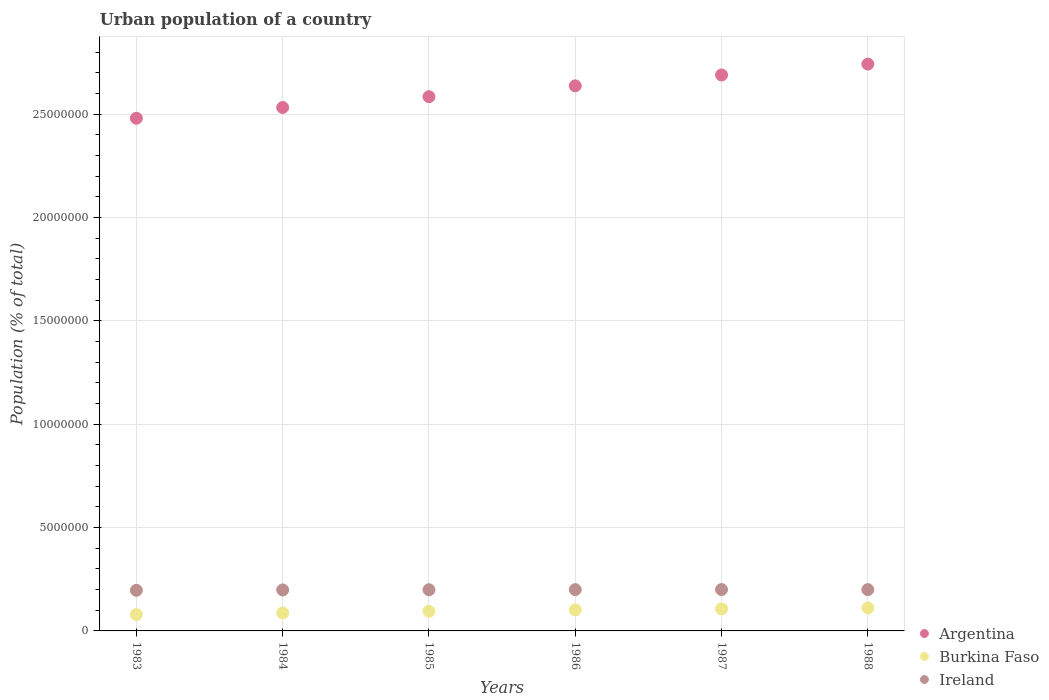Is the number of dotlines equal to the number of legend labels?
Offer a terse response. Yes. What is the urban population in Argentina in 1988?
Keep it short and to the point. 2.74e+07. Across all years, what is the maximum urban population in Ireland?
Provide a short and direct response. 2.00e+06. Across all years, what is the minimum urban population in Argentina?
Offer a very short reply. 2.48e+07. What is the total urban population in Burkina Faso in the graph?
Your response must be concise. 5.81e+06. What is the difference between the urban population in Burkina Faso in 1984 and that in 1987?
Your answer should be compact. -1.95e+05. What is the difference between the urban population in Ireland in 1985 and the urban population in Argentina in 1986?
Your answer should be very brief. -2.44e+07. What is the average urban population in Burkina Faso per year?
Give a very brief answer. 9.68e+05. In the year 1986, what is the difference between the urban population in Argentina and urban population in Burkina Faso?
Your response must be concise. 2.53e+07. What is the ratio of the urban population in Burkina Faso in 1983 to that in 1985?
Provide a succinct answer. 0.83. Is the difference between the urban population in Argentina in 1987 and 1988 greater than the difference between the urban population in Burkina Faso in 1987 and 1988?
Your answer should be compact. No. What is the difference between the highest and the second highest urban population in Burkina Faso?
Offer a terse response. 4.87e+04. What is the difference between the highest and the lowest urban population in Burkina Faso?
Provide a succinct answer. 3.20e+05. Does the urban population in Burkina Faso monotonically increase over the years?
Offer a very short reply. Yes. Is the urban population in Burkina Faso strictly greater than the urban population in Argentina over the years?
Keep it short and to the point. No. Is the urban population in Burkina Faso strictly less than the urban population in Ireland over the years?
Make the answer very short. Yes. How many years are there in the graph?
Keep it short and to the point. 6. What is the difference between two consecutive major ticks on the Y-axis?
Ensure brevity in your answer.  5.00e+06. How many legend labels are there?
Provide a succinct answer. 3. How are the legend labels stacked?
Provide a succinct answer. Vertical. What is the title of the graph?
Give a very brief answer. Urban population of a country. What is the label or title of the Y-axis?
Your response must be concise. Population (% of total). What is the Population (% of total) in Argentina in 1983?
Your response must be concise. 2.48e+07. What is the Population (% of total) of Burkina Faso in 1983?
Keep it short and to the point. 7.93e+05. What is the Population (% of total) of Ireland in 1983?
Give a very brief answer. 1.96e+06. What is the Population (% of total) of Argentina in 1984?
Keep it short and to the point. 2.53e+07. What is the Population (% of total) in Burkina Faso in 1984?
Make the answer very short. 8.69e+05. What is the Population (% of total) of Ireland in 1984?
Your answer should be compact. 1.98e+06. What is the Population (% of total) of Argentina in 1985?
Ensure brevity in your answer.  2.58e+07. What is the Population (% of total) in Burkina Faso in 1985?
Make the answer very short. 9.53e+05. What is the Population (% of total) in Ireland in 1985?
Provide a succinct answer. 1.99e+06. What is the Population (% of total) of Argentina in 1986?
Your response must be concise. 2.64e+07. What is the Population (% of total) in Burkina Faso in 1986?
Provide a succinct answer. 1.02e+06. What is the Population (% of total) of Ireland in 1986?
Your answer should be compact. 2.00e+06. What is the Population (% of total) of Argentina in 1987?
Offer a very short reply. 2.69e+07. What is the Population (% of total) in Burkina Faso in 1987?
Provide a short and direct response. 1.06e+06. What is the Population (% of total) of Ireland in 1987?
Ensure brevity in your answer.  2.00e+06. What is the Population (% of total) in Argentina in 1988?
Keep it short and to the point. 2.74e+07. What is the Population (% of total) of Burkina Faso in 1988?
Give a very brief answer. 1.11e+06. What is the Population (% of total) of Ireland in 1988?
Ensure brevity in your answer.  2.00e+06. Across all years, what is the maximum Population (% of total) of Argentina?
Offer a terse response. 2.74e+07. Across all years, what is the maximum Population (% of total) in Burkina Faso?
Ensure brevity in your answer.  1.11e+06. Across all years, what is the maximum Population (% of total) of Ireland?
Offer a terse response. 2.00e+06. Across all years, what is the minimum Population (% of total) of Argentina?
Offer a terse response. 2.48e+07. Across all years, what is the minimum Population (% of total) of Burkina Faso?
Offer a very short reply. 7.93e+05. Across all years, what is the minimum Population (% of total) in Ireland?
Provide a short and direct response. 1.96e+06. What is the total Population (% of total) of Argentina in the graph?
Your answer should be very brief. 1.57e+08. What is the total Population (% of total) of Burkina Faso in the graph?
Your answer should be very brief. 5.81e+06. What is the total Population (% of total) of Ireland in the graph?
Ensure brevity in your answer.  1.19e+07. What is the difference between the Population (% of total) of Argentina in 1983 and that in 1984?
Offer a very short reply. -5.20e+05. What is the difference between the Population (% of total) of Burkina Faso in 1983 and that in 1984?
Your response must be concise. -7.69e+04. What is the difference between the Population (% of total) of Ireland in 1983 and that in 1984?
Make the answer very short. -1.79e+04. What is the difference between the Population (% of total) of Argentina in 1983 and that in 1985?
Offer a very short reply. -1.04e+06. What is the difference between the Population (% of total) in Burkina Faso in 1983 and that in 1985?
Ensure brevity in your answer.  -1.61e+05. What is the difference between the Population (% of total) in Ireland in 1983 and that in 1985?
Make the answer very short. -2.67e+04. What is the difference between the Population (% of total) in Argentina in 1983 and that in 1986?
Your response must be concise. -1.57e+06. What is the difference between the Population (% of total) of Burkina Faso in 1983 and that in 1986?
Provide a succinct answer. -2.25e+05. What is the difference between the Population (% of total) in Ireland in 1983 and that in 1986?
Ensure brevity in your answer.  -3.29e+04. What is the difference between the Population (% of total) in Argentina in 1983 and that in 1987?
Provide a short and direct response. -2.09e+06. What is the difference between the Population (% of total) in Burkina Faso in 1983 and that in 1987?
Keep it short and to the point. -2.72e+05. What is the difference between the Population (% of total) in Ireland in 1983 and that in 1987?
Keep it short and to the point. -3.74e+04. What is the difference between the Population (% of total) of Argentina in 1983 and that in 1988?
Offer a very short reply. -2.62e+06. What is the difference between the Population (% of total) of Burkina Faso in 1983 and that in 1988?
Your response must be concise. -3.20e+05. What is the difference between the Population (% of total) in Ireland in 1983 and that in 1988?
Give a very brief answer. -3.31e+04. What is the difference between the Population (% of total) of Argentina in 1984 and that in 1985?
Offer a very short reply. -5.23e+05. What is the difference between the Population (% of total) in Burkina Faso in 1984 and that in 1985?
Offer a very short reply. -8.38e+04. What is the difference between the Population (% of total) in Ireland in 1984 and that in 1985?
Your answer should be compact. -8837. What is the difference between the Population (% of total) in Argentina in 1984 and that in 1986?
Your response must be concise. -1.05e+06. What is the difference between the Population (% of total) in Burkina Faso in 1984 and that in 1986?
Offer a terse response. -1.48e+05. What is the difference between the Population (% of total) in Ireland in 1984 and that in 1986?
Your answer should be very brief. -1.51e+04. What is the difference between the Population (% of total) in Argentina in 1984 and that in 1987?
Give a very brief answer. -1.57e+06. What is the difference between the Population (% of total) of Burkina Faso in 1984 and that in 1987?
Offer a terse response. -1.95e+05. What is the difference between the Population (% of total) of Ireland in 1984 and that in 1987?
Your answer should be compact. -1.95e+04. What is the difference between the Population (% of total) of Argentina in 1984 and that in 1988?
Ensure brevity in your answer.  -2.10e+06. What is the difference between the Population (% of total) of Burkina Faso in 1984 and that in 1988?
Your answer should be compact. -2.43e+05. What is the difference between the Population (% of total) of Ireland in 1984 and that in 1988?
Offer a very short reply. -1.52e+04. What is the difference between the Population (% of total) of Argentina in 1985 and that in 1986?
Offer a very short reply. -5.24e+05. What is the difference between the Population (% of total) in Burkina Faso in 1985 and that in 1986?
Your answer should be compact. -6.45e+04. What is the difference between the Population (% of total) of Ireland in 1985 and that in 1986?
Provide a short and direct response. -6249. What is the difference between the Population (% of total) of Argentina in 1985 and that in 1987?
Your answer should be very brief. -1.05e+06. What is the difference between the Population (% of total) of Burkina Faso in 1985 and that in 1987?
Offer a terse response. -1.11e+05. What is the difference between the Population (% of total) of Ireland in 1985 and that in 1987?
Provide a succinct answer. -1.07e+04. What is the difference between the Population (% of total) of Argentina in 1985 and that in 1988?
Your answer should be very brief. -1.58e+06. What is the difference between the Population (% of total) of Burkina Faso in 1985 and that in 1988?
Keep it short and to the point. -1.60e+05. What is the difference between the Population (% of total) of Ireland in 1985 and that in 1988?
Provide a succinct answer. -6392. What is the difference between the Population (% of total) of Argentina in 1986 and that in 1987?
Your response must be concise. -5.26e+05. What is the difference between the Population (% of total) in Burkina Faso in 1986 and that in 1987?
Offer a very short reply. -4.64e+04. What is the difference between the Population (% of total) of Ireland in 1986 and that in 1987?
Provide a short and direct response. -4456. What is the difference between the Population (% of total) in Argentina in 1986 and that in 1988?
Your response must be concise. -1.05e+06. What is the difference between the Population (% of total) of Burkina Faso in 1986 and that in 1988?
Offer a very short reply. -9.51e+04. What is the difference between the Population (% of total) in Ireland in 1986 and that in 1988?
Your answer should be compact. -143. What is the difference between the Population (% of total) in Argentina in 1987 and that in 1988?
Provide a succinct answer. -5.27e+05. What is the difference between the Population (% of total) of Burkina Faso in 1987 and that in 1988?
Give a very brief answer. -4.87e+04. What is the difference between the Population (% of total) in Ireland in 1987 and that in 1988?
Provide a short and direct response. 4313. What is the difference between the Population (% of total) in Argentina in 1983 and the Population (% of total) in Burkina Faso in 1984?
Keep it short and to the point. 2.39e+07. What is the difference between the Population (% of total) of Argentina in 1983 and the Population (% of total) of Ireland in 1984?
Make the answer very short. 2.28e+07. What is the difference between the Population (% of total) of Burkina Faso in 1983 and the Population (% of total) of Ireland in 1984?
Provide a succinct answer. -1.19e+06. What is the difference between the Population (% of total) of Argentina in 1983 and the Population (% of total) of Burkina Faso in 1985?
Keep it short and to the point. 2.38e+07. What is the difference between the Population (% of total) of Argentina in 1983 and the Population (% of total) of Ireland in 1985?
Your answer should be compact. 2.28e+07. What is the difference between the Population (% of total) in Burkina Faso in 1983 and the Population (% of total) in Ireland in 1985?
Offer a very short reply. -1.20e+06. What is the difference between the Population (% of total) in Argentina in 1983 and the Population (% of total) in Burkina Faso in 1986?
Your answer should be very brief. 2.38e+07. What is the difference between the Population (% of total) of Argentina in 1983 and the Population (% of total) of Ireland in 1986?
Your answer should be compact. 2.28e+07. What is the difference between the Population (% of total) of Burkina Faso in 1983 and the Population (% of total) of Ireland in 1986?
Your answer should be compact. -1.20e+06. What is the difference between the Population (% of total) in Argentina in 1983 and the Population (% of total) in Burkina Faso in 1987?
Offer a terse response. 2.37e+07. What is the difference between the Population (% of total) of Argentina in 1983 and the Population (% of total) of Ireland in 1987?
Your answer should be compact. 2.28e+07. What is the difference between the Population (% of total) in Burkina Faso in 1983 and the Population (% of total) in Ireland in 1987?
Provide a succinct answer. -1.21e+06. What is the difference between the Population (% of total) in Argentina in 1983 and the Population (% of total) in Burkina Faso in 1988?
Offer a terse response. 2.37e+07. What is the difference between the Population (% of total) in Argentina in 1983 and the Population (% of total) in Ireland in 1988?
Make the answer very short. 2.28e+07. What is the difference between the Population (% of total) of Burkina Faso in 1983 and the Population (% of total) of Ireland in 1988?
Your response must be concise. -1.20e+06. What is the difference between the Population (% of total) in Argentina in 1984 and the Population (% of total) in Burkina Faso in 1985?
Give a very brief answer. 2.44e+07. What is the difference between the Population (% of total) in Argentina in 1984 and the Population (% of total) in Ireland in 1985?
Ensure brevity in your answer.  2.33e+07. What is the difference between the Population (% of total) of Burkina Faso in 1984 and the Population (% of total) of Ireland in 1985?
Make the answer very short. -1.12e+06. What is the difference between the Population (% of total) in Argentina in 1984 and the Population (% of total) in Burkina Faso in 1986?
Your response must be concise. 2.43e+07. What is the difference between the Population (% of total) in Argentina in 1984 and the Population (% of total) in Ireland in 1986?
Your answer should be compact. 2.33e+07. What is the difference between the Population (% of total) of Burkina Faso in 1984 and the Population (% of total) of Ireland in 1986?
Your response must be concise. -1.13e+06. What is the difference between the Population (% of total) of Argentina in 1984 and the Population (% of total) of Burkina Faso in 1987?
Keep it short and to the point. 2.43e+07. What is the difference between the Population (% of total) in Argentina in 1984 and the Population (% of total) in Ireland in 1987?
Your answer should be very brief. 2.33e+07. What is the difference between the Population (% of total) in Burkina Faso in 1984 and the Population (% of total) in Ireland in 1987?
Offer a terse response. -1.13e+06. What is the difference between the Population (% of total) of Argentina in 1984 and the Population (% of total) of Burkina Faso in 1988?
Offer a very short reply. 2.42e+07. What is the difference between the Population (% of total) of Argentina in 1984 and the Population (% of total) of Ireland in 1988?
Offer a very short reply. 2.33e+07. What is the difference between the Population (% of total) of Burkina Faso in 1984 and the Population (% of total) of Ireland in 1988?
Make the answer very short. -1.13e+06. What is the difference between the Population (% of total) in Argentina in 1985 and the Population (% of total) in Burkina Faso in 1986?
Offer a terse response. 2.48e+07. What is the difference between the Population (% of total) of Argentina in 1985 and the Population (% of total) of Ireland in 1986?
Make the answer very short. 2.38e+07. What is the difference between the Population (% of total) of Burkina Faso in 1985 and the Population (% of total) of Ireland in 1986?
Ensure brevity in your answer.  -1.04e+06. What is the difference between the Population (% of total) in Argentina in 1985 and the Population (% of total) in Burkina Faso in 1987?
Give a very brief answer. 2.48e+07. What is the difference between the Population (% of total) of Argentina in 1985 and the Population (% of total) of Ireland in 1987?
Offer a very short reply. 2.38e+07. What is the difference between the Population (% of total) of Burkina Faso in 1985 and the Population (% of total) of Ireland in 1987?
Provide a short and direct response. -1.05e+06. What is the difference between the Population (% of total) of Argentina in 1985 and the Population (% of total) of Burkina Faso in 1988?
Provide a succinct answer. 2.47e+07. What is the difference between the Population (% of total) in Argentina in 1985 and the Population (% of total) in Ireland in 1988?
Offer a very short reply. 2.38e+07. What is the difference between the Population (% of total) in Burkina Faso in 1985 and the Population (% of total) in Ireland in 1988?
Make the answer very short. -1.04e+06. What is the difference between the Population (% of total) in Argentina in 1986 and the Population (% of total) in Burkina Faso in 1987?
Your response must be concise. 2.53e+07. What is the difference between the Population (% of total) in Argentina in 1986 and the Population (% of total) in Ireland in 1987?
Ensure brevity in your answer.  2.44e+07. What is the difference between the Population (% of total) of Burkina Faso in 1986 and the Population (% of total) of Ireland in 1987?
Your answer should be compact. -9.84e+05. What is the difference between the Population (% of total) in Argentina in 1986 and the Population (% of total) in Burkina Faso in 1988?
Give a very brief answer. 2.53e+07. What is the difference between the Population (% of total) in Argentina in 1986 and the Population (% of total) in Ireland in 1988?
Provide a short and direct response. 2.44e+07. What is the difference between the Population (% of total) in Burkina Faso in 1986 and the Population (% of total) in Ireland in 1988?
Keep it short and to the point. -9.80e+05. What is the difference between the Population (% of total) in Argentina in 1987 and the Population (% of total) in Burkina Faso in 1988?
Make the answer very short. 2.58e+07. What is the difference between the Population (% of total) of Argentina in 1987 and the Population (% of total) of Ireland in 1988?
Your answer should be compact. 2.49e+07. What is the difference between the Population (% of total) of Burkina Faso in 1987 and the Population (% of total) of Ireland in 1988?
Your response must be concise. -9.33e+05. What is the average Population (% of total) in Argentina per year?
Your response must be concise. 2.61e+07. What is the average Population (% of total) in Burkina Faso per year?
Your answer should be compact. 9.68e+05. What is the average Population (% of total) in Ireland per year?
Offer a very short reply. 1.99e+06. In the year 1983, what is the difference between the Population (% of total) of Argentina and Population (% of total) of Burkina Faso?
Your answer should be very brief. 2.40e+07. In the year 1983, what is the difference between the Population (% of total) of Argentina and Population (% of total) of Ireland?
Provide a short and direct response. 2.28e+07. In the year 1983, what is the difference between the Population (% of total) in Burkina Faso and Population (% of total) in Ireland?
Offer a very short reply. -1.17e+06. In the year 1984, what is the difference between the Population (% of total) in Argentina and Population (% of total) in Burkina Faso?
Your response must be concise. 2.44e+07. In the year 1984, what is the difference between the Population (% of total) in Argentina and Population (% of total) in Ireland?
Ensure brevity in your answer.  2.33e+07. In the year 1984, what is the difference between the Population (% of total) of Burkina Faso and Population (% of total) of Ireland?
Keep it short and to the point. -1.11e+06. In the year 1985, what is the difference between the Population (% of total) in Argentina and Population (% of total) in Burkina Faso?
Make the answer very short. 2.49e+07. In the year 1985, what is the difference between the Population (% of total) in Argentina and Population (% of total) in Ireland?
Provide a short and direct response. 2.39e+07. In the year 1985, what is the difference between the Population (% of total) of Burkina Faso and Population (% of total) of Ireland?
Your response must be concise. -1.04e+06. In the year 1986, what is the difference between the Population (% of total) in Argentina and Population (% of total) in Burkina Faso?
Your answer should be very brief. 2.53e+07. In the year 1986, what is the difference between the Population (% of total) in Argentina and Population (% of total) in Ireland?
Make the answer very short. 2.44e+07. In the year 1986, what is the difference between the Population (% of total) in Burkina Faso and Population (% of total) in Ireland?
Your answer should be very brief. -9.80e+05. In the year 1987, what is the difference between the Population (% of total) of Argentina and Population (% of total) of Burkina Faso?
Make the answer very short. 2.58e+07. In the year 1987, what is the difference between the Population (% of total) of Argentina and Population (% of total) of Ireland?
Give a very brief answer. 2.49e+07. In the year 1987, what is the difference between the Population (% of total) in Burkina Faso and Population (% of total) in Ireland?
Keep it short and to the point. -9.38e+05. In the year 1988, what is the difference between the Population (% of total) in Argentina and Population (% of total) in Burkina Faso?
Provide a succinct answer. 2.63e+07. In the year 1988, what is the difference between the Population (% of total) of Argentina and Population (% of total) of Ireland?
Your answer should be compact. 2.54e+07. In the year 1988, what is the difference between the Population (% of total) of Burkina Faso and Population (% of total) of Ireland?
Provide a short and direct response. -8.85e+05. What is the ratio of the Population (% of total) in Argentina in 1983 to that in 1984?
Provide a short and direct response. 0.98. What is the ratio of the Population (% of total) of Burkina Faso in 1983 to that in 1984?
Your answer should be very brief. 0.91. What is the ratio of the Population (% of total) of Argentina in 1983 to that in 1985?
Your response must be concise. 0.96. What is the ratio of the Population (% of total) in Burkina Faso in 1983 to that in 1985?
Keep it short and to the point. 0.83. What is the ratio of the Population (% of total) in Ireland in 1983 to that in 1985?
Your answer should be very brief. 0.99. What is the ratio of the Population (% of total) in Argentina in 1983 to that in 1986?
Your answer should be compact. 0.94. What is the ratio of the Population (% of total) in Burkina Faso in 1983 to that in 1986?
Ensure brevity in your answer.  0.78. What is the ratio of the Population (% of total) in Ireland in 1983 to that in 1986?
Ensure brevity in your answer.  0.98. What is the ratio of the Population (% of total) of Argentina in 1983 to that in 1987?
Provide a short and direct response. 0.92. What is the ratio of the Population (% of total) of Burkina Faso in 1983 to that in 1987?
Provide a short and direct response. 0.74. What is the ratio of the Population (% of total) of Ireland in 1983 to that in 1987?
Keep it short and to the point. 0.98. What is the ratio of the Population (% of total) of Argentina in 1983 to that in 1988?
Offer a terse response. 0.9. What is the ratio of the Population (% of total) of Burkina Faso in 1983 to that in 1988?
Offer a very short reply. 0.71. What is the ratio of the Population (% of total) in Ireland in 1983 to that in 1988?
Your response must be concise. 0.98. What is the ratio of the Population (% of total) of Argentina in 1984 to that in 1985?
Offer a terse response. 0.98. What is the ratio of the Population (% of total) in Burkina Faso in 1984 to that in 1985?
Offer a terse response. 0.91. What is the ratio of the Population (% of total) in Argentina in 1984 to that in 1986?
Give a very brief answer. 0.96. What is the ratio of the Population (% of total) of Burkina Faso in 1984 to that in 1986?
Offer a very short reply. 0.85. What is the ratio of the Population (% of total) of Ireland in 1984 to that in 1986?
Your response must be concise. 0.99. What is the ratio of the Population (% of total) in Argentina in 1984 to that in 1987?
Ensure brevity in your answer.  0.94. What is the ratio of the Population (% of total) of Burkina Faso in 1984 to that in 1987?
Give a very brief answer. 0.82. What is the ratio of the Population (% of total) of Ireland in 1984 to that in 1987?
Give a very brief answer. 0.99. What is the ratio of the Population (% of total) of Argentina in 1984 to that in 1988?
Ensure brevity in your answer.  0.92. What is the ratio of the Population (% of total) of Burkina Faso in 1984 to that in 1988?
Make the answer very short. 0.78. What is the ratio of the Population (% of total) of Ireland in 1984 to that in 1988?
Your answer should be very brief. 0.99. What is the ratio of the Population (% of total) in Argentina in 1985 to that in 1986?
Offer a very short reply. 0.98. What is the ratio of the Population (% of total) in Burkina Faso in 1985 to that in 1986?
Provide a short and direct response. 0.94. What is the ratio of the Population (% of total) of Burkina Faso in 1985 to that in 1987?
Offer a very short reply. 0.9. What is the ratio of the Population (% of total) of Argentina in 1985 to that in 1988?
Offer a terse response. 0.94. What is the ratio of the Population (% of total) of Burkina Faso in 1985 to that in 1988?
Provide a succinct answer. 0.86. What is the ratio of the Population (% of total) of Argentina in 1986 to that in 1987?
Your response must be concise. 0.98. What is the ratio of the Population (% of total) of Burkina Faso in 1986 to that in 1987?
Give a very brief answer. 0.96. What is the ratio of the Population (% of total) of Ireland in 1986 to that in 1987?
Provide a succinct answer. 1. What is the ratio of the Population (% of total) of Argentina in 1986 to that in 1988?
Your answer should be very brief. 0.96. What is the ratio of the Population (% of total) of Burkina Faso in 1986 to that in 1988?
Keep it short and to the point. 0.91. What is the ratio of the Population (% of total) in Argentina in 1987 to that in 1988?
Your response must be concise. 0.98. What is the ratio of the Population (% of total) in Burkina Faso in 1987 to that in 1988?
Your answer should be very brief. 0.96. What is the ratio of the Population (% of total) of Ireland in 1987 to that in 1988?
Keep it short and to the point. 1. What is the difference between the highest and the second highest Population (% of total) of Argentina?
Ensure brevity in your answer.  5.27e+05. What is the difference between the highest and the second highest Population (% of total) in Burkina Faso?
Give a very brief answer. 4.87e+04. What is the difference between the highest and the second highest Population (% of total) in Ireland?
Make the answer very short. 4313. What is the difference between the highest and the lowest Population (% of total) in Argentina?
Ensure brevity in your answer.  2.62e+06. What is the difference between the highest and the lowest Population (% of total) in Burkina Faso?
Provide a short and direct response. 3.20e+05. What is the difference between the highest and the lowest Population (% of total) in Ireland?
Offer a terse response. 3.74e+04. 